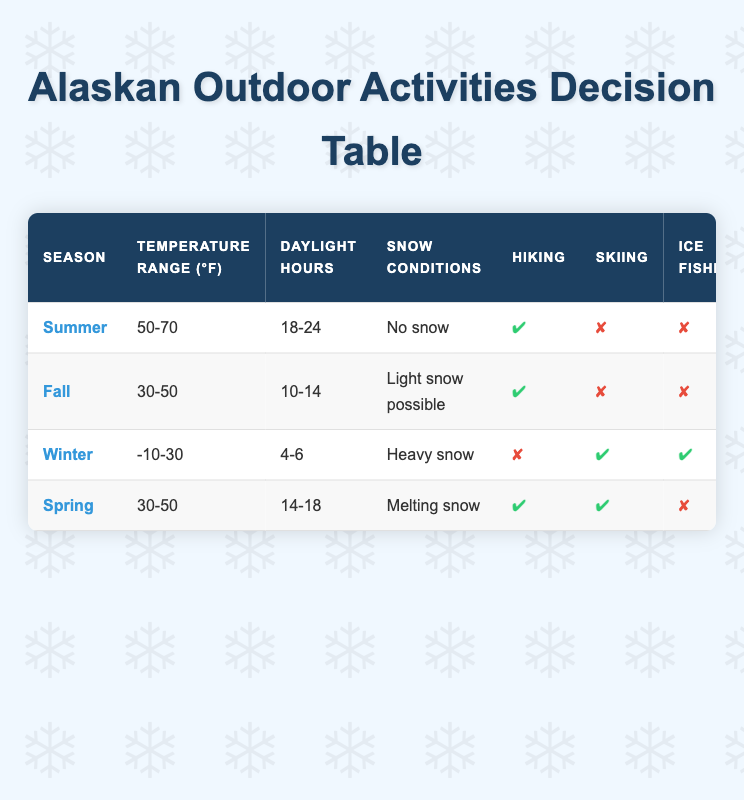What activities can I do in summer? In summer, you can go hiking, kayaking, berry picking, and wildlife watching. It has no snow, pleasant temperatures between 50-70°F, and the longest daytime hours of 18-24.
Answer: Hiking, Kayaking, Berry Picking, Wildlife Watching Is skiing an option in fall? No, skiing is not an option in fall since the table indicates it is marked as false for that season, despite light snow being possible.
Answer: No What is the temperature range during winter? The winter temperature range is between -10°F and 30°F. This can be found directly in the table under the winter season row.
Answer: -10-30°F Can you go ice fishing in spring? No, you cannot go ice fishing in spring as it is marked as false in the table. The conditions during this season indicate melting snow, making it unsuitable for ice fishing.
Answer: No Which activities can be done when there are heavy snow conditions? When there are heavy snow conditions, you can ski, ice fish, view the northern lights, dog sled, and watch wildlife. In winter, those activities are marked as true.
Answer: Skiing, Ice Fishing, Northern Lights Viewing, Dog Sledding, Wildlife Watching How many outdoor activities can you do during fall? You can do four outdoor activities during fall: hiking, northern lights viewing, berry picking, and wildlife watching, as indicated by the true/false markings.
Answer: 4 Is there any season where all activities are available? No, there is no season where all activities are available; each season has specific activities marked as true or false. For instance, in summer, skiing, ice fishing, and dog sledding are not possible.
Answer: No What is the difference in daylight hours between summer and winter? The daylight hours in summer range from 18 to 24, while in winter, they range from 4 to 6. The difference in maximum daylight hours is 24 - 6 = 18 hours.
Answer: 18 hours How many activities can be done in spring compared to summer? In spring, there are five activities you can do: hiking, skiing, kayaking, and wildlife watching. In summer, there are also four activities. The difference is 5 - 4 = 1 more activity in spring than in summer.
Answer: 1 more activity in spring 